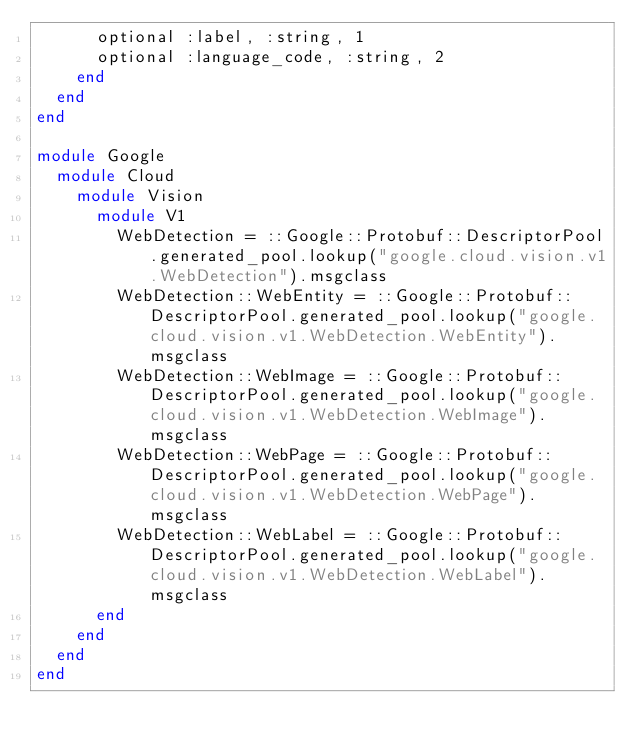<code> <loc_0><loc_0><loc_500><loc_500><_Ruby_>      optional :label, :string, 1
      optional :language_code, :string, 2
    end
  end
end

module Google
  module Cloud
    module Vision
      module V1
        WebDetection = ::Google::Protobuf::DescriptorPool.generated_pool.lookup("google.cloud.vision.v1.WebDetection").msgclass
        WebDetection::WebEntity = ::Google::Protobuf::DescriptorPool.generated_pool.lookup("google.cloud.vision.v1.WebDetection.WebEntity").msgclass
        WebDetection::WebImage = ::Google::Protobuf::DescriptorPool.generated_pool.lookup("google.cloud.vision.v1.WebDetection.WebImage").msgclass
        WebDetection::WebPage = ::Google::Protobuf::DescriptorPool.generated_pool.lookup("google.cloud.vision.v1.WebDetection.WebPage").msgclass
        WebDetection::WebLabel = ::Google::Protobuf::DescriptorPool.generated_pool.lookup("google.cloud.vision.v1.WebDetection.WebLabel").msgclass
      end
    end
  end
end
</code> 